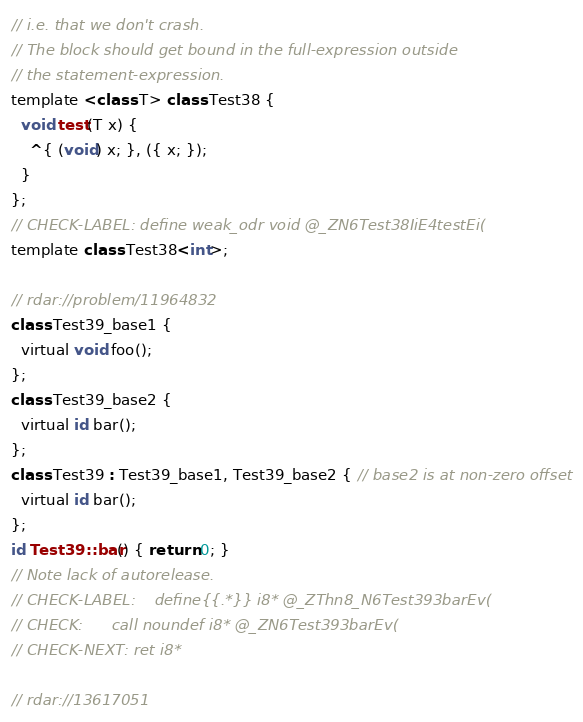Convert code to text. <code><loc_0><loc_0><loc_500><loc_500><_ObjectiveC_>// i.e. that we don't crash.
// The block should get bound in the full-expression outside
// the statement-expression.
template <class T> class Test38 {
  void test(T x) {
    ^{ (void) x; }, ({ x; });
  }
};
// CHECK-LABEL: define weak_odr void @_ZN6Test38IiE4testEi(
template class Test38<int>;

// rdar://problem/11964832
class Test39_base1 {
  virtual void foo();
};
class Test39_base2 {
  virtual id bar();
};
class Test39 : Test39_base1, Test39_base2 { // base2 is at non-zero offset
  virtual id bar();
};
id Test39::bar() { return 0; }
// Note lack of autorelease.
// CHECK-LABEL:    define{{.*}} i8* @_ZThn8_N6Test393barEv(
// CHECK:      call noundef i8* @_ZN6Test393barEv(
// CHECK-NEXT: ret i8*

// rdar://13617051</code> 